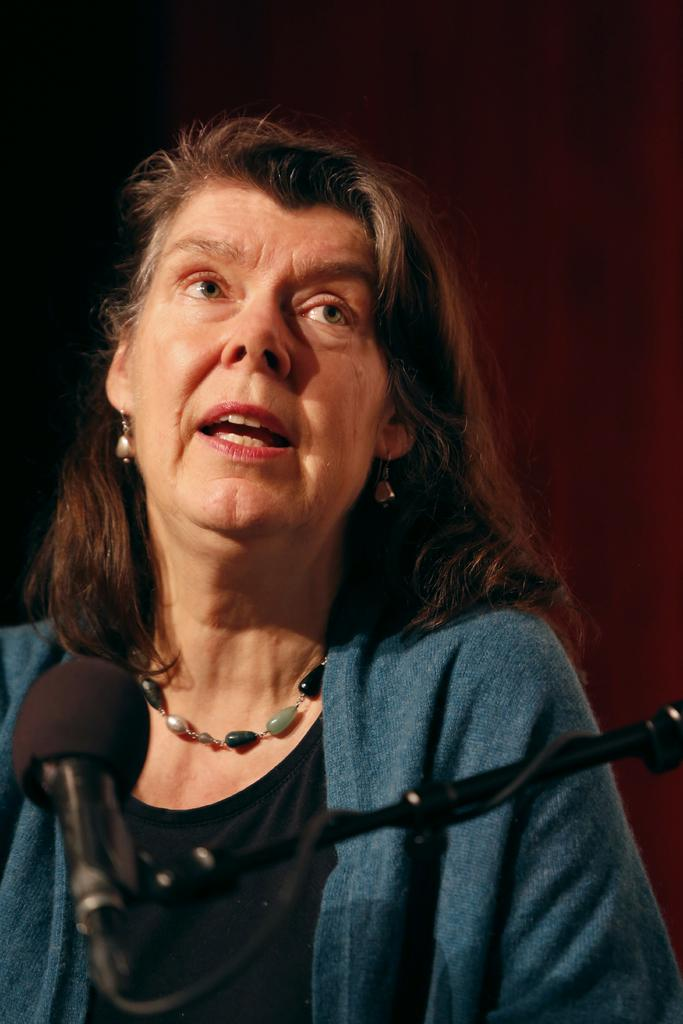What can be seen on the stand in the image? There is a mic and wire on the stand in the image. Who is standing behind the mic? There is a lady behind the mic. What is the lady wearing around her neck? The lady is wearing a chain around her neck. What type of beast can be seen in the image? There is no beast present in the image; it features a stand with a mic and wire, and a lady behind the mic. 